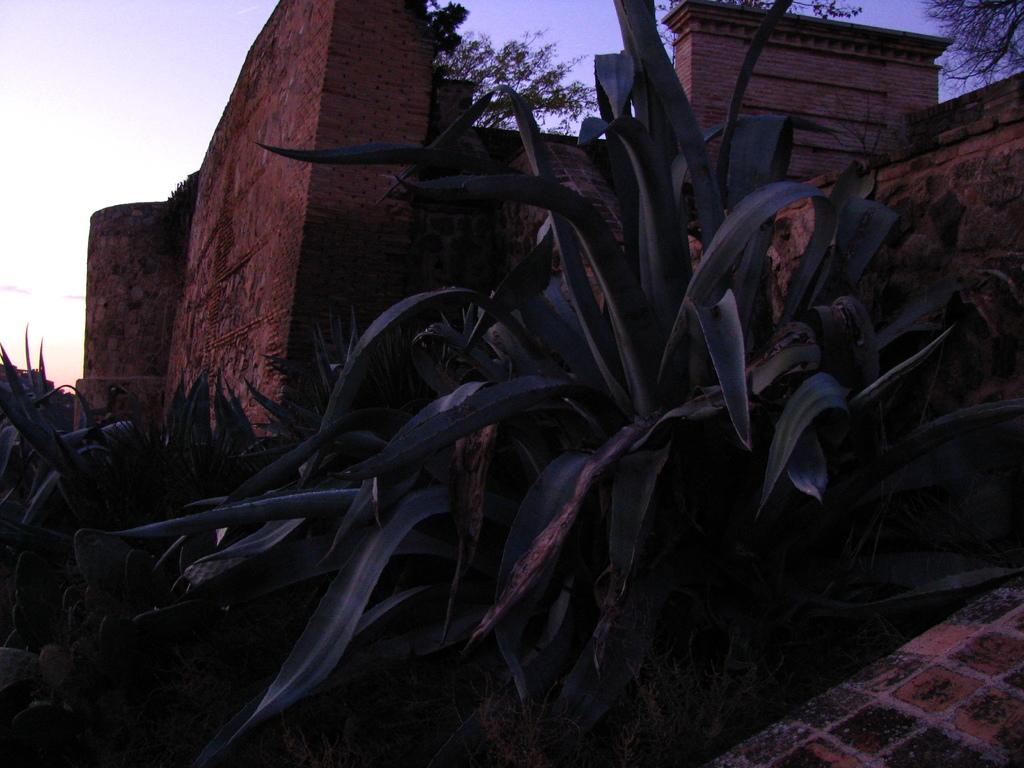What is the main feature in the foreground of the image? There are many plants in the foreground of the image. What type of wall can be seen in the middle of the image? There is a wall made of rocks in the middle of the image. What can be seen in the background of the image? The sky is visible in the background of the image. What type of agreement is being discussed by the porter in the image? There is no porter present in the image, and therefore no discussion of an agreement can be observed. How many stitches are visible on the plants in the image? The plants in the image do not have stitches, as they are living organisms and not sewn objects. 